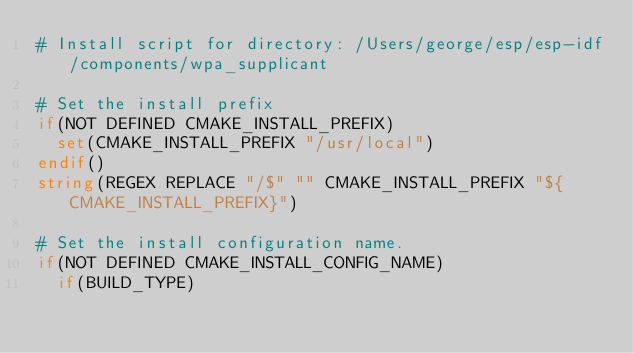<code> <loc_0><loc_0><loc_500><loc_500><_CMake_># Install script for directory: /Users/george/esp/esp-idf/components/wpa_supplicant

# Set the install prefix
if(NOT DEFINED CMAKE_INSTALL_PREFIX)
  set(CMAKE_INSTALL_PREFIX "/usr/local")
endif()
string(REGEX REPLACE "/$" "" CMAKE_INSTALL_PREFIX "${CMAKE_INSTALL_PREFIX}")

# Set the install configuration name.
if(NOT DEFINED CMAKE_INSTALL_CONFIG_NAME)
  if(BUILD_TYPE)</code> 